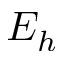<formula> <loc_0><loc_0><loc_500><loc_500>E _ { h }</formula> 